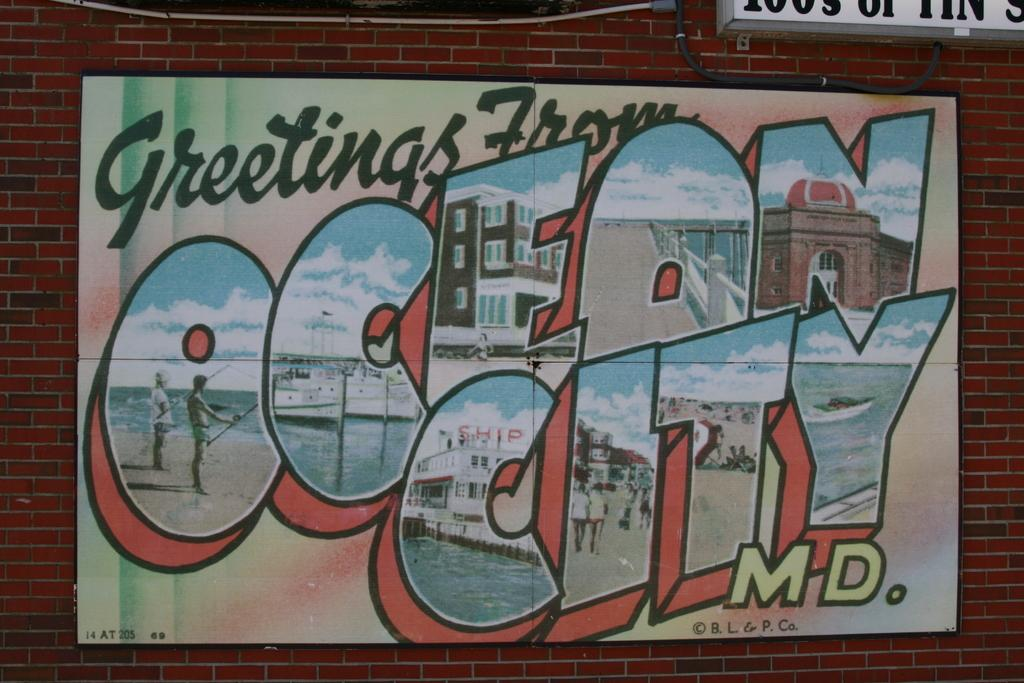<image>
Render a clear and concise summary of the photo. A postcard sending greetings from Ocean City Maryland. 